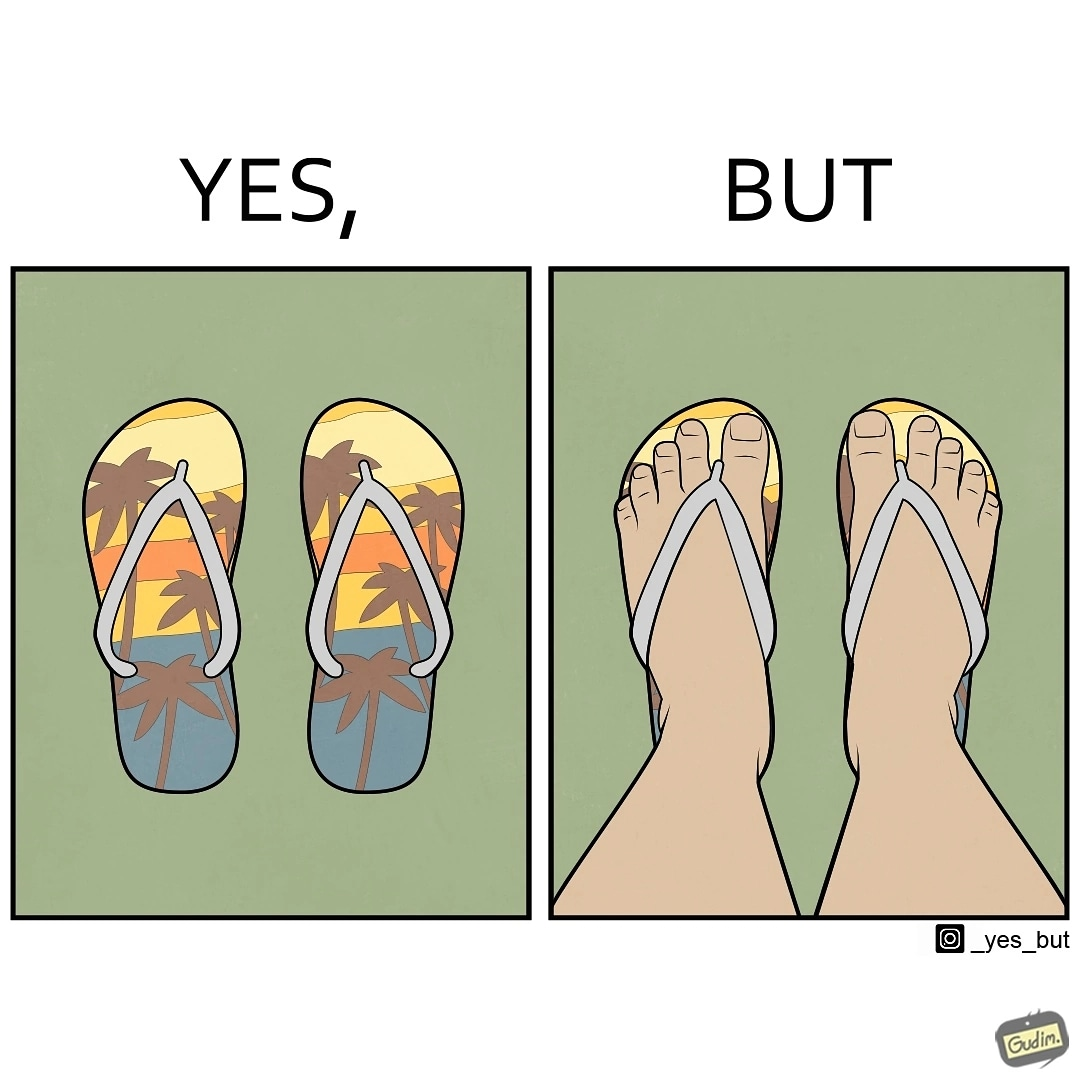Describe what you see in this image. The image is ironical, as when a person wear a pair of slippers with a colorful image, it is almost completely hidden due to the legs of the person wearing the slippers, which counters the point of having such colorful slippers. 